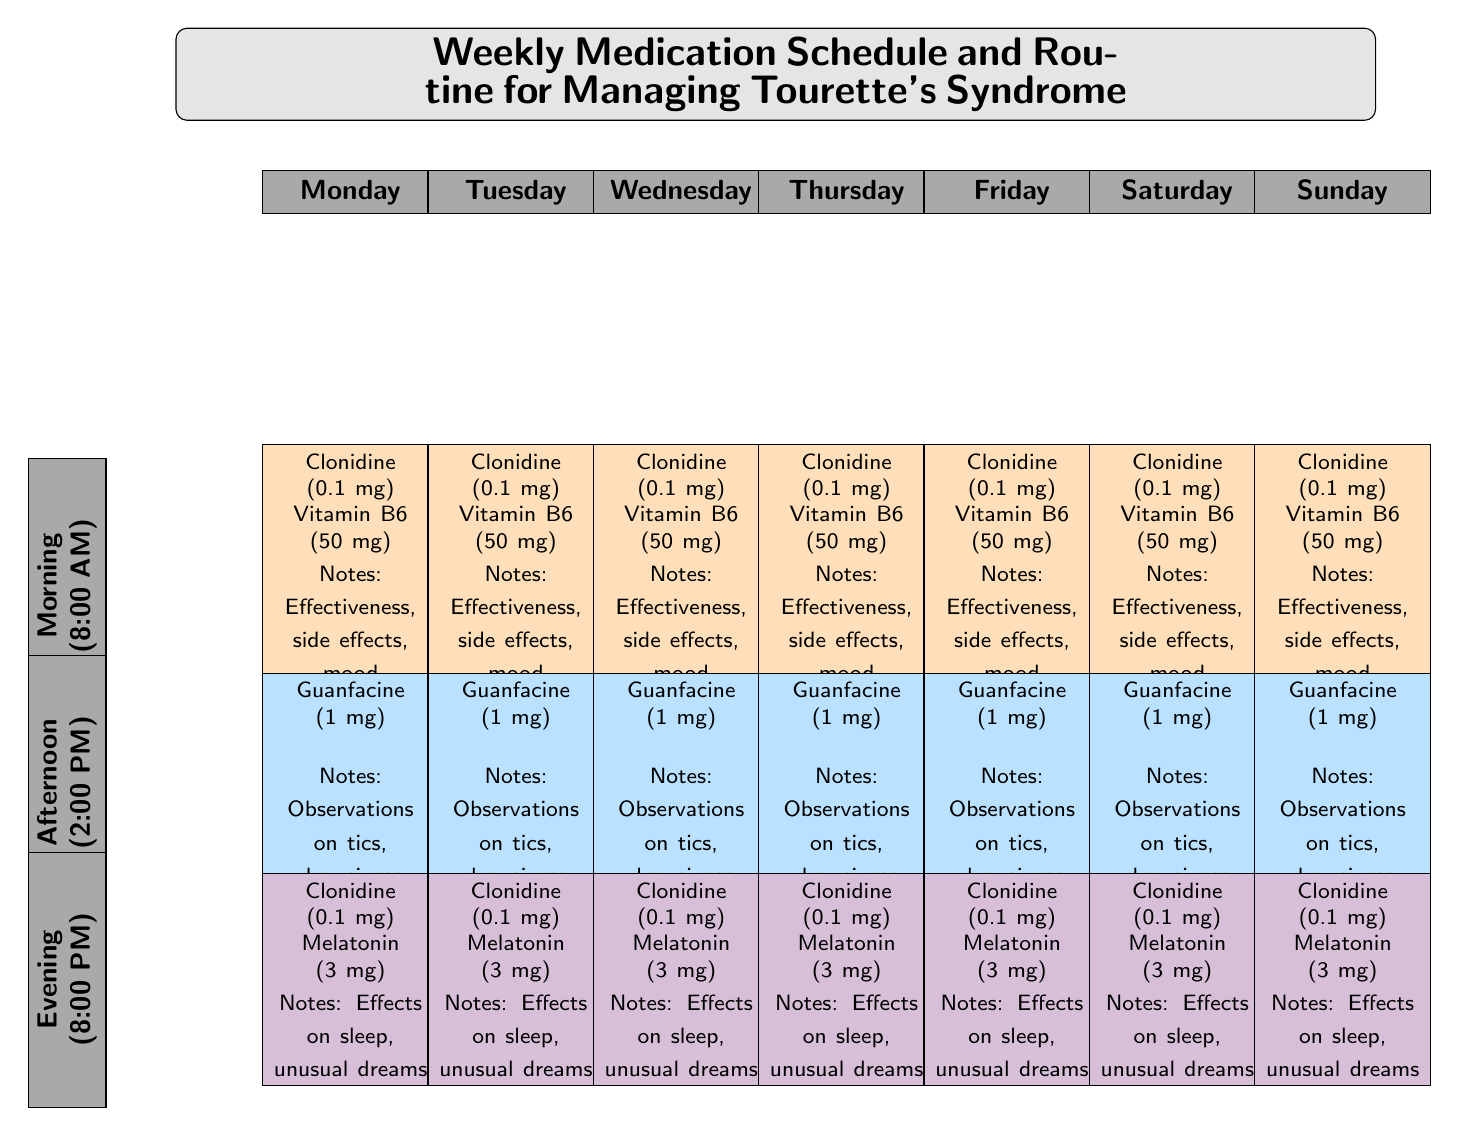What medications are administered in the morning? The diagram indicates that in the morning (8:00 AM), the medications prescribed are Clonidine (0.1 mg) and Vitamin B6 (50 mg).
Answer: Clonidine (0.1 mg), Vitamin B6 (50 mg) What is the dosage of Guanfacine? The diagram specifies that the dosage of Guanfacine is 1 mg in the afternoon.
Answer: 1 mg Which medication is taken in the evening? According to the diagram, the medications prescribed in the evening (8:00 PM) are Clonidine (0.1 mg) and Melatonin (3 mg).
Answer: Clonidine (0.1 mg), Melatonin (3 mg) How many notes should be made in the morning section? The morning section includes a note on effectiveness, side effects, and mood improvements, which totals three notes.
Answer: 3 Which day has the same medications as Tuesday in the evening? The diagram indicates that the evening medications are the same for every day, which means all days have the same medications as Tuesday.
Answer: All days How would you differentiate between the colors used for different times of day? In the diagram, the morning cells are colored in a peach shade (morningColor), the afternoon cells are in a light blue shade (afternoonColor), and the evening cells are in a light purple shade (eveningColor).
Answer: Peach (morning), light blue (afternoon), light purple (evening) What purpose do the notes serve in the medication schedule? The notes provide important observations about the effectiveness and side effects of medications, along with additional remarks, helping track the treatment's impact.
Answer: Observations and tracking treatment impact What is the orientation of the medication schedule for time slots? The medication schedule for time slots (Morning, Afternoon, Evening) is oriented vertically, as the time slots are rotated 90 degrees to fit the layout.
Answer: Vertically rotated 